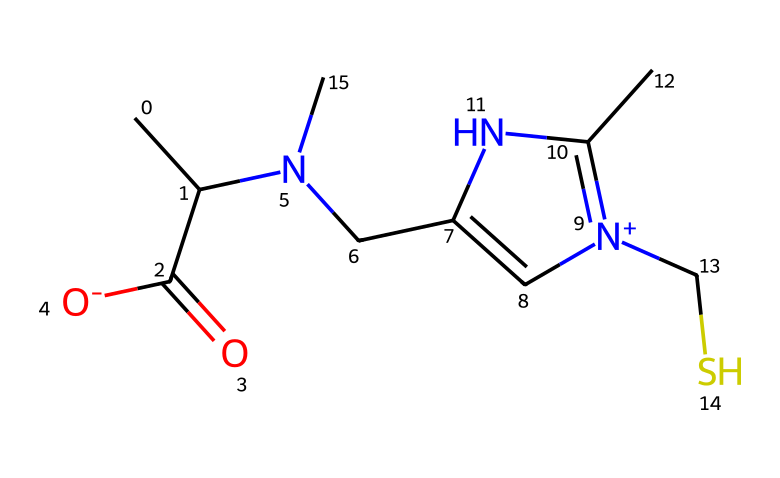What is the molecular formula of ergothioneine? To derive the molecular formula, count the atoms of each element in the SMILES. The structure includes carbon (C), hydrogen (H), nitrogen (N), oxygen (O), and sulfur (S) atoms. Counting reveals there are 10 carbons, 15 hydrogens, 2 nitrogens, 1 oxygen, and 1 sulfur. Thus, combining them gives C10H15N2O1S1.
Answer: C10H15N2OS How many nitrogen atoms are in the ergothioneine structure? The SMILES representation includes two nitrogen atoms, which can be identified within the structure where there are two instances of "[N]" indicated.
Answer: 2 What type of antioxidant properties does ergothioneine exhibit? Ergothioneine is known to exhibit the properties of a powerful antioxidant, specifically acting to scavenge free radicals. Its sulfur content contributes significantly to its antioxidant activity.
Answer: powerful antioxidant Which part of ergothioneine's structure is responsible for its sulfur-containing nature? The presence of the sulfur atom (indicated by "S" in the SMILES) connected to the ring structure shows that ergothioneine is indeed a sulfur-containing compound. This sulfur atom is pivotal for its classification as an organosulfur compound.
Answer: sulfur atom How many rings are present in the chemical structure of ergothioneine? By analyzing the SMILES representation, the ring structure can be identified where carbon atoms form a closed-loop around nitrogen and sulfur. There is one distinct ring involving the nitrogen atoms and carbon framework.
Answer: 1 What class of compounds does ergothioneine belong to? Given its structure includes sulfur and is derived from biological sources, ergothioneine is classified as an organosulfur compound.
Answer: organosulfur compound 